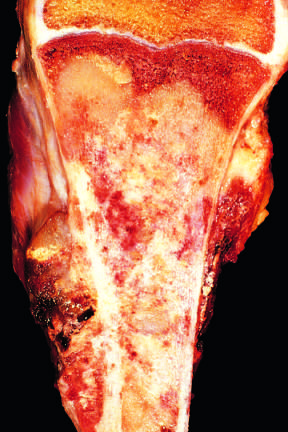does extensive mucous plugging and dilation of the tracheobronchial tree fill most of the medullary cavity of the metaphysis and proximal diaphysis?
Answer the question using a single word or phrase. No 